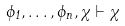Convert formula to latex. <formula><loc_0><loc_0><loc_500><loc_500>\phi _ { 1 } , \dots , \phi _ { n } , \chi \vdash \chi</formula> 